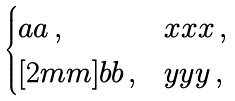<formula> <loc_0><loc_0><loc_500><loc_500>\begin{cases} a a \, , & x x x \, , \\ [ 2 m m ] b b \, , & y y y \, , \end{cases}</formula> 